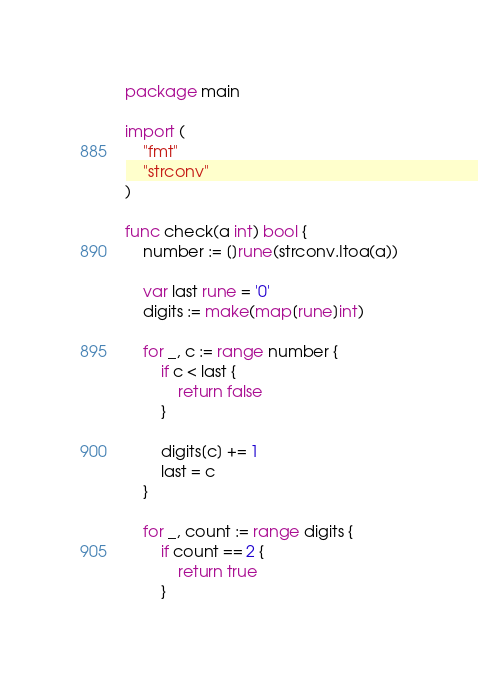<code> <loc_0><loc_0><loc_500><loc_500><_Go_>package main

import (
	"fmt"
	"strconv"
)

func check(a int) bool {
	number := []rune(strconv.Itoa(a))

	var last rune = '0'
	digits := make(map[rune]int)

	for _, c := range number {
		if c < last {
			return false
		}

		digits[c] += 1
		last = c
	}

	for _, count := range digits {
		if count == 2 {
			return true
		}</code> 